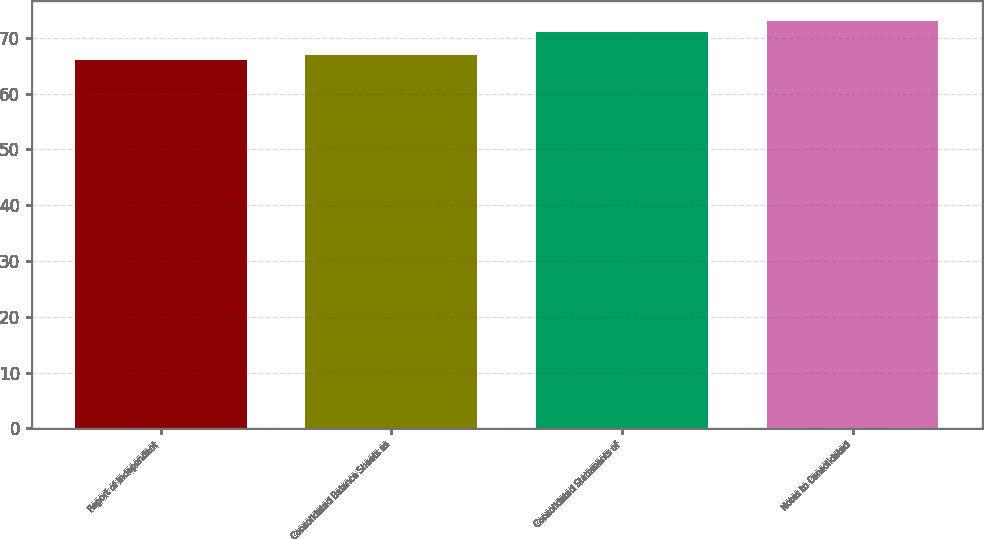Convert chart to OTSL. <chart><loc_0><loc_0><loc_500><loc_500><bar_chart><fcel>Report of Independent<fcel>Consolidated Balance Sheets as<fcel>Consolidated Statements of<fcel>Notes to Consolidated<nl><fcel>66<fcel>67<fcel>71<fcel>73<nl></chart> 